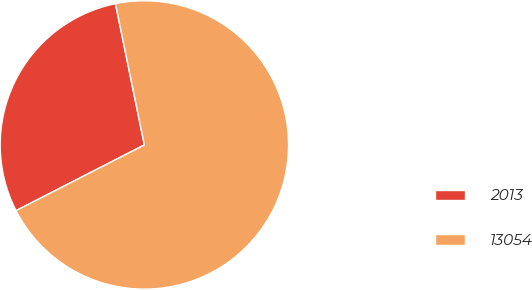Convert chart. <chart><loc_0><loc_0><loc_500><loc_500><pie_chart><fcel>2013<fcel>13054<nl><fcel>29.32%<fcel>70.68%<nl></chart> 